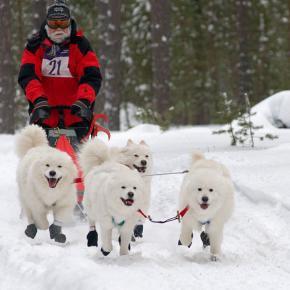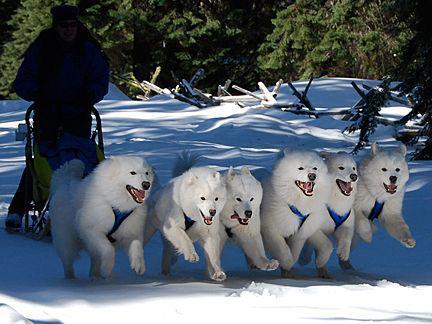The first image is the image on the left, the second image is the image on the right. Given the left and right images, does the statement "There is a man wearing red outerwear on a sled." hold true? Answer yes or no. Yes. 